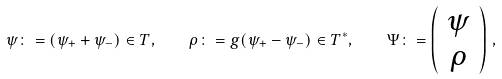Convert formula to latex. <formula><loc_0><loc_0><loc_500><loc_500>\psi \colon = ( \psi _ { + } + \psi _ { - } ) \in T , \quad \rho \colon = g ( \psi _ { + } - \psi _ { - } ) \in T ^ { * } , \quad \Psi \colon = \left ( \begin{array} { c } \psi \\ \rho \end{array} \right ) \, ,</formula> 